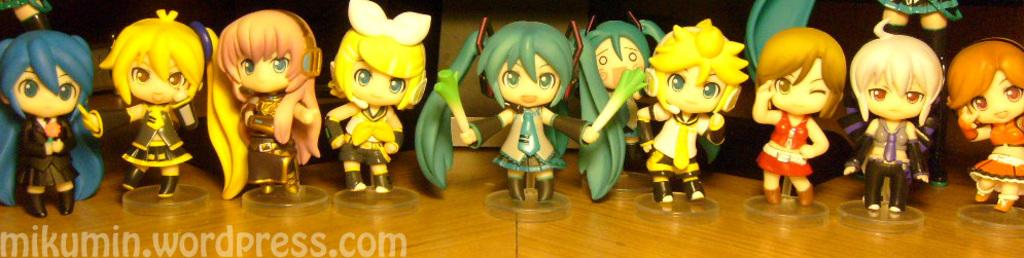What type of toys are on the wooden table in the image? There are doll toys on a wooden table in the image. Can you describe the table in the image? The table is made of wood. Is there any text or message in the image? Yes, there is a small quote at the bottom of the image. How many dogs are playing with the doll toys in the image? There are no dogs present in the image; it features doll toys on a wooden table and a small quote at the bottom. What fictional character might be interacting with the doll toys in the image? There is no fictional character depicted in the image; it only shows doll toys on a wooden table and a small quote at the bottom. 